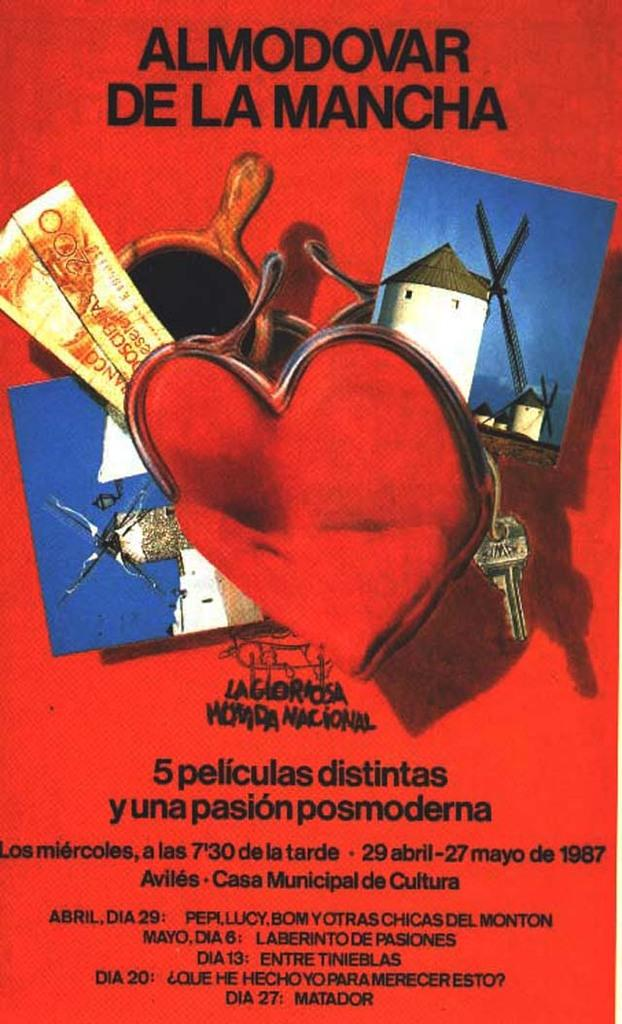<image>
Summarize the visual content of the image. Windmills are on a red poster for an event that will be taking place with the dates and the times located on the bottom of the poster. 